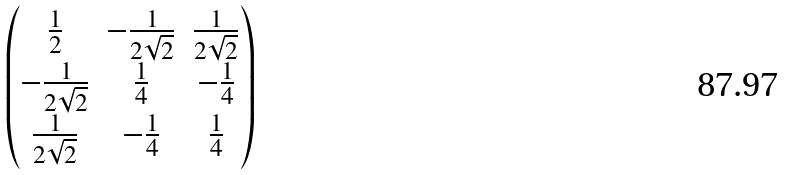Convert formula to latex. <formula><loc_0><loc_0><loc_500><loc_500>\begin{pmatrix} \frac { 1 } { 2 } & - \frac { 1 } { 2 \sqrt { 2 } } & \frac { 1 } { 2 \sqrt { 2 } } \\ - \frac { 1 } { 2 \sqrt { 2 } } & \frac { 1 } { 4 } & - \frac { 1 } { 4 } \\ \frac { 1 } { 2 \sqrt { 2 } } & - \frac { 1 } { 4 } & \frac { 1 } { 4 } \end{pmatrix}</formula> 